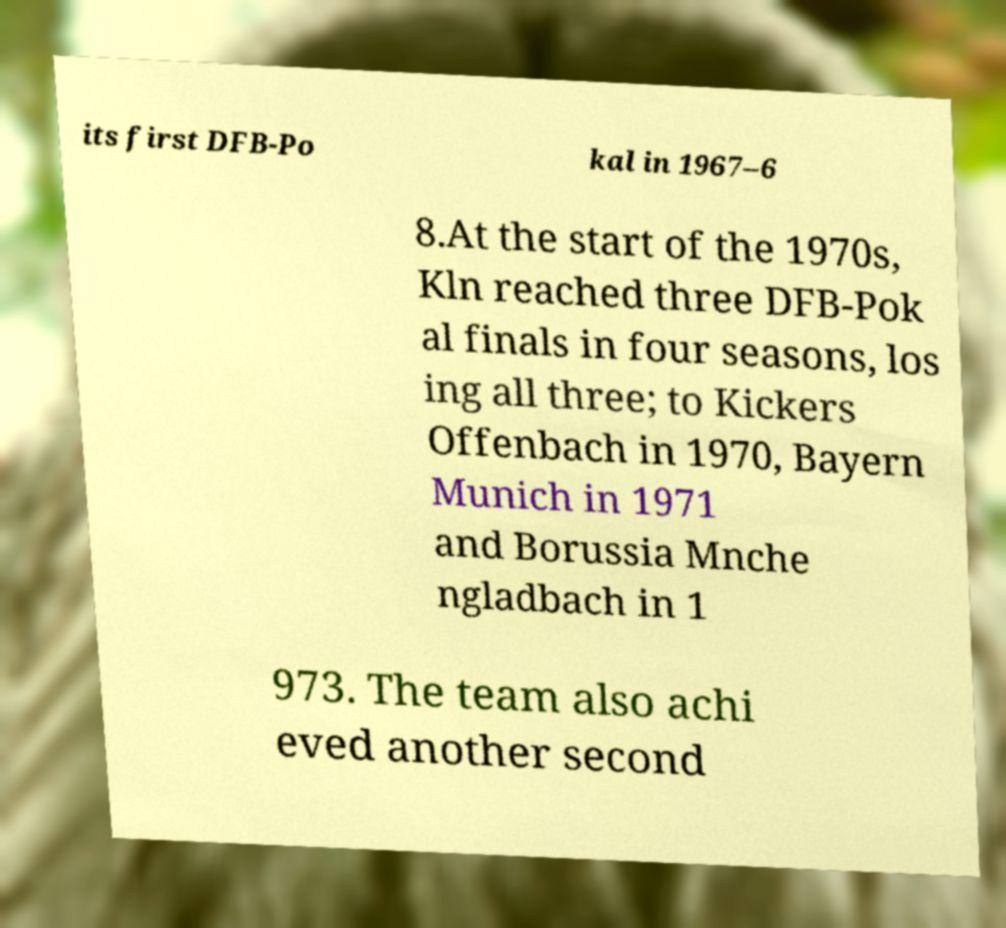Please read and relay the text visible in this image. What does it say? its first DFB-Po kal in 1967–6 8.At the start of the 1970s, Kln reached three DFB-Pok al finals in four seasons, los ing all three; to Kickers Offenbach in 1970, Bayern Munich in 1971 and Borussia Mnche ngladbach in 1 973. The team also achi eved another second 